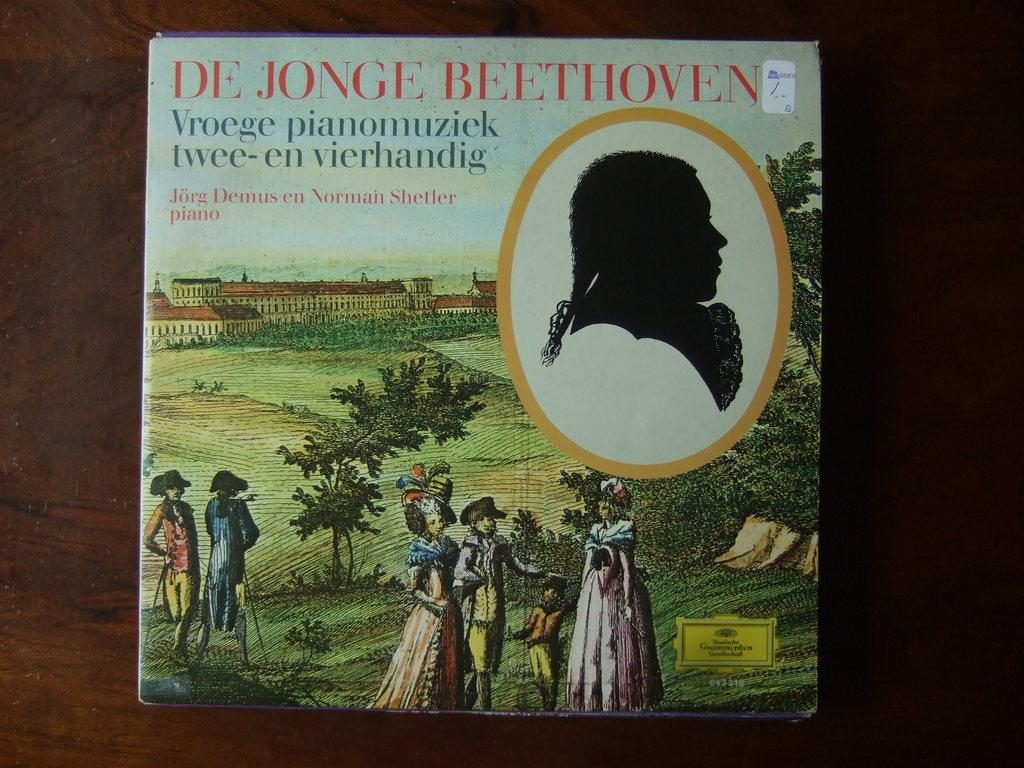Provide a one-sentence caption for the provided image. A HARD COVERED BOOK CALLED DE JONGE BEETHOVEN. 